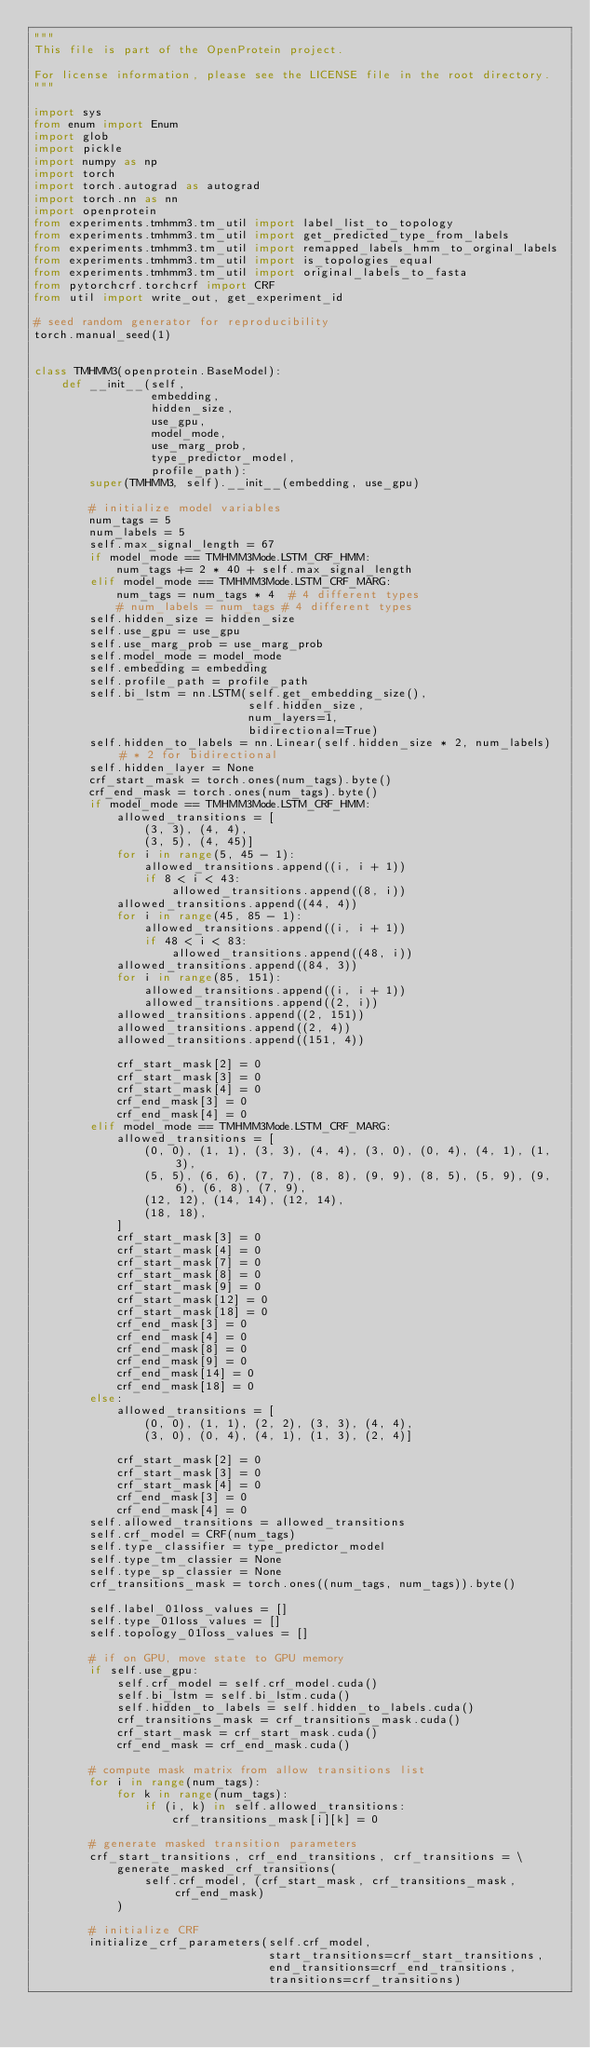<code> <loc_0><loc_0><loc_500><loc_500><_Python_>"""
This file is part of the OpenProtein project.

For license information, please see the LICENSE file in the root directory.
"""

import sys
from enum import Enum
import glob
import pickle
import numpy as np
import torch
import torch.autograd as autograd
import torch.nn as nn
import openprotein
from experiments.tmhmm3.tm_util import label_list_to_topology
from experiments.tmhmm3.tm_util import get_predicted_type_from_labels
from experiments.tmhmm3.tm_util import remapped_labels_hmm_to_orginal_labels
from experiments.tmhmm3.tm_util import is_topologies_equal
from experiments.tmhmm3.tm_util import original_labels_to_fasta
from pytorchcrf.torchcrf import CRF
from util import write_out, get_experiment_id

# seed random generator for reproducibility
torch.manual_seed(1)


class TMHMM3(openprotein.BaseModel):
    def __init__(self,
                 embedding,
                 hidden_size,
                 use_gpu,
                 model_mode,
                 use_marg_prob,
                 type_predictor_model,
                 profile_path):
        super(TMHMM3, self).__init__(embedding, use_gpu)

        # initialize model variables
        num_tags = 5
        num_labels = 5
        self.max_signal_length = 67
        if model_mode == TMHMM3Mode.LSTM_CRF_HMM:
            num_tags += 2 * 40 + self.max_signal_length
        elif model_mode == TMHMM3Mode.LSTM_CRF_MARG:
            num_tags = num_tags * 4  # 4 different types
            # num_labels = num_tags # 4 different types
        self.hidden_size = hidden_size
        self.use_gpu = use_gpu
        self.use_marg_prob = use_marg_prob
        self.model_mode = model_mode
        self.embedding = embedding
        self.profile_path = profile_path
        self.bi_lstm = nn.LSTM(self.get_embedding_size(),
                               self.hidden_size,
                               num_layers=1,
                               bidirectional=True)
        self.hidden_to_labels = nn.Linear(self.hidden_size * 2, num_labels)  # * 2 for bidirectional
        self.hidden_layer = None
        crf_start_mask = torch.ones(num_tags).byte()
        crf_end_mask = torch.ones(num_tags).byte()
        if model_mode == TMHMM3Mode.LSTM_CRF_HMM:
            allowed_transitions = [
                (3, 3), (4, 4),
                (3, 5), (4, 45)]
            for i in range(5, 45 - 1):
                allowed_transitions.append((i, i + 1))
                if 8 < i < 43:
                    allowed_transitions.append((8, i))
            allowed_transitions.append((44, 4))
            for i in range(45, 85 - 1):
                allowed_transitions.append((i, i + 1))
                if 48 < i < 83:
                    allowed_transitions.append((48, i))
            allowed_transitions.append((84, 3))
            for i in range(85, 151):
                allowed_transitions.append((i, i + 1))
                allowed_transitions.append((2, i))
            allowed_transitions.append((2, 151))
            allowed_transitions.append((2, 4))
            allowed_transitions.append((151, 4))

            crf_start_mask[2] = 0
            crf_start_mask[3] = 0
            crf_start_mask[4] = 0
            crf_end_mask[3] = 0
            crf_end_mask[4] = 0
        elif model_mode == TMHMM3Mode.LSTM_CRF_MARG:
            allowed_transitions = [
                (0, 0), (1, 1), (3, 3), (4, 4), (3, 0), (0, 4), (4, 1), (1, 3),
                (5, 5), (6, 6), (7, 7), (8, 8), (9, 9), (8, 5), (5, 9), (9, 6), (6, 8), (7, 9),
                (12, 12), (14, 14), (12, 14),
                (18, 18),
            ]
            crf_start_mask[3] = 0
            crf_start_mask[4] = 0
            crf_start_mask[7] = 0
            crf_start_mask[8] = 0
            crf_start_mask[9] = 0
            crf_start_mask[12] = 0
            crf_start_mask[18] = 0
            crf_end_mask[3] = 0
            crf_end_mask[4] = 0
            crf_end_mask[8] = 0
            crf_end_mask[9] = 0
            crf_end_mask[14] = 0
            crf_end_mask[18] = 0
        else:
            allowed_transitions = [
                (0, 0), (1, 1), (2, 2), (3, 3), (4, 4),
                (3, 0), (0, 4), (4, 1), (1, 3), (2, 4)]

            crf_start_mask[2] = 0
            crf_start_mask[3] = 0
            crf_start_mask[4] = 0
            crf_end_mask[3] = 0
            crf_end_mask[4] = 0
        self.allowed_transitions = allowed_transitions
        self.crf_model = CRF(num_tags)
        self.type_classifier = type_predictor_model
        self.type_tm_classier = None
        self.type_sp_classier = None
        crf_transitions_mask = torch.ones((num_tags, num_tags)).byte()

        self.label_01loss_values = []
        self.type_01loss_values = []
        self.topology_01loss_values = []

        # if on GPU, move state to GPU memory
        if self.use_gpu:
            self.crf_model = self.crf_model.cuda()
            self.bi_lstm = self.bi_lstm.cuda()
            self.hidden_to_labels = self.hidden_to_labels.cuda()
            crf_transitions_mask = crf_transitions_mask.cuda()
            crf_start_mask = crf_start_mask.cuda()
            crf_end_mask = crf_end_mask.cuda()

        # compute mask matrix from allow transitions list
        for i in range(num_tags):
            for k in range(num_tags):
                if (i, k) in self.allowed_transitions:
                    crf_transitions_mask[i][k] = 0

        # generate masked transition parameters
        crf_start_transitions, crf_end_transitions, crf_transitions = \
            generate_masked_crf_transitions(
                self.crf_model, (crf_start_mask, crf_transitions_mask, crf_end_mask)
            )

        # initialize CRF
        initialize_crf_parameters(self.crf_model,
                                  start_transitions=crf_start_transitions,
                                  end_transitions=crf_end_transitions,
                                  transitions=crf_transitions)
</code> 